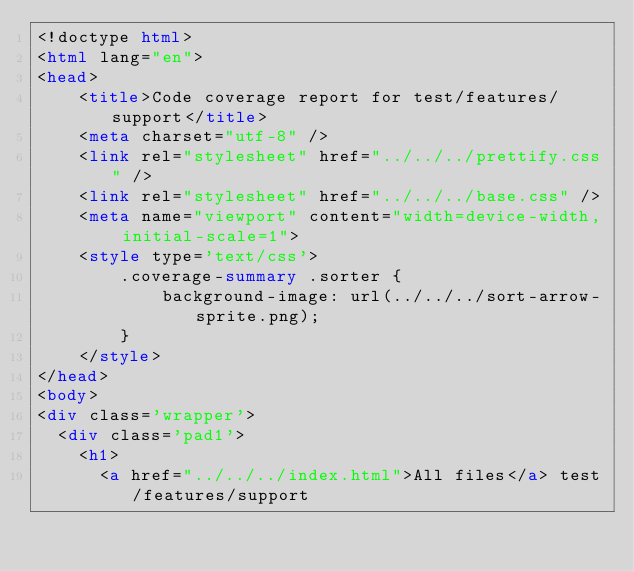<code> <loc_0><loc_0><loc_500><loc_500><_HTML_><!doctype html>
<html lang="en">
<head>
    <title>Code coverage report for test/features/support</title>
    <meta charset="utf-8" />
    <link rel="stylesheet" href="../../../prettify.css" />
    <link rel="stylesheet" href="../../../base.css" />
    <meta name="viewport" content="width=device-width, initial-scale=1">
    <style type='text/css'>
        .coverage-summary .sorter {
            background-image: url(../../../sort-arrow-sprite.png);
        }
    </style>
</head>
<body>
<div class='wrapper'>
  <div class='pad1'>
    <h1>
      <a href="../../../index.html">All files</a> test/features/support</code> 